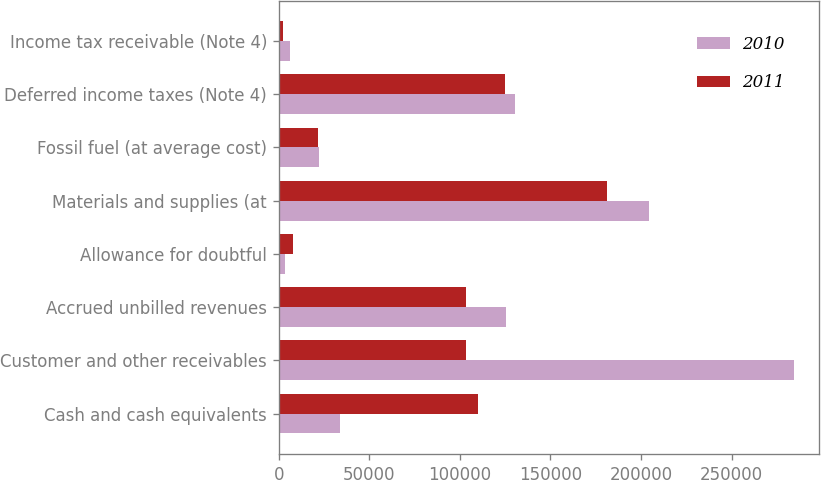<chart> <loc_0><loc_0><loc_500><loc_500><stacked_bar_chart><ecel><fcel>Cash and cash equivalents<fcel>Customer and other receivables<fcel>Accrued unbilled revenues<fcel>Allowance for doubtful<fcel>Materials and supplies (at<fcel>Fossil fuel (at average cost)<fcel>Deferred income taxes (Note 4)<fcel>Income tax receivable (Note 4)<nl><fcel>2010<fcel>33583<fcel>284183<fcel>125239<fcel>3748<fcel>204387<fcel>22000<fcel>130571<fcel>6466<nl><fcel>2011<fcel>110188<fcel>103292<fcel>103292<fcel>7981<fcel>181414<fcel>21575<fcel>124897<fcel>2483<nl></chart> 